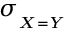<formula> <loc_0><loc_0><loc_500><loc_500>\sigma _ { _ { X = Y } }</formula> 